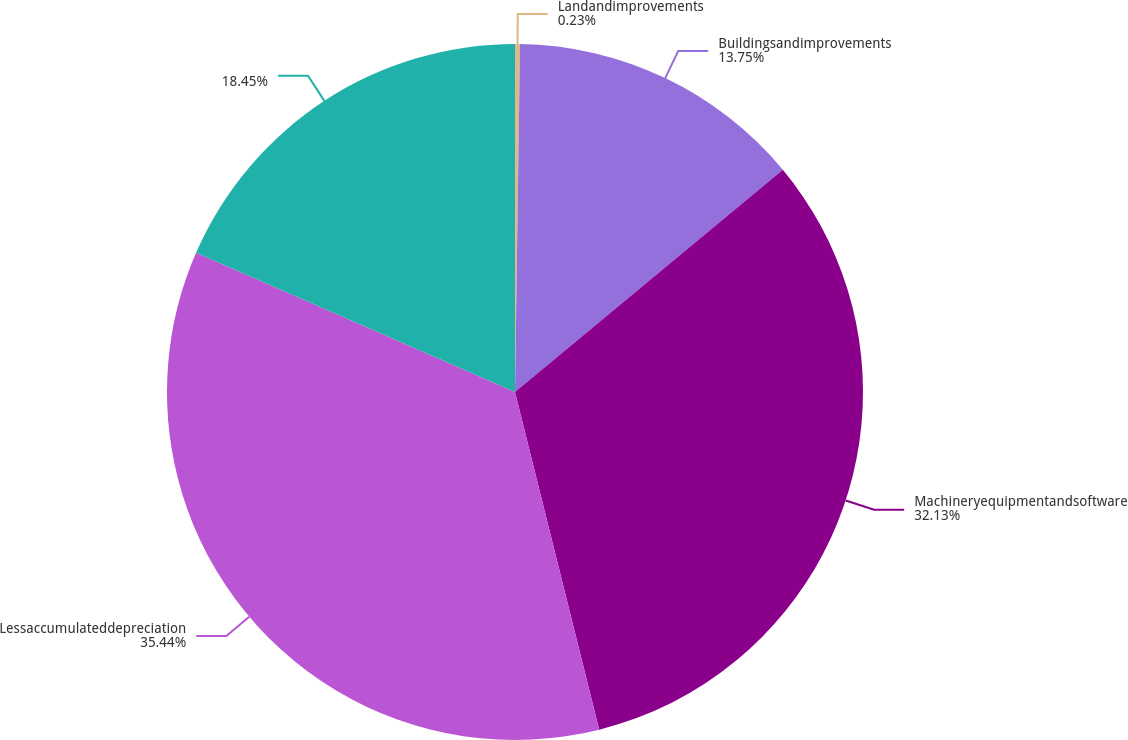Convert chart to OTSL. <chart><loc_0><loc_0><loc_500><loc_500><pie_chart><fcel>Landandimprovements<fcel>Buildingsandimprovements<fcel>Machineryequipmentandsoftware<fcel>Lessaccumulateddepreciation<fcel>Unnamed: 4<nl><fcel>0.23%<fcel>13.75%<fcel>32.13%<fcel>35.44%<fcel>18.45%<nl></chart> 